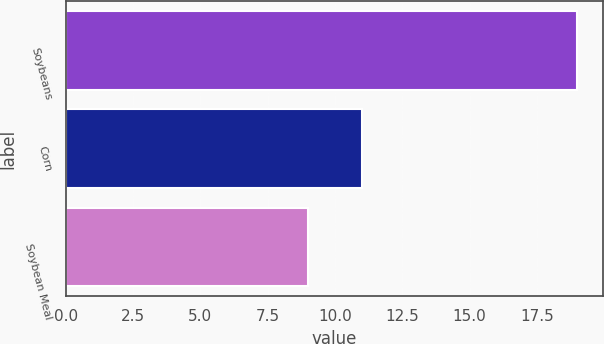Convert chart. <chart><loc_0><loc_0><loc_500><loc_500><bar_chart><fcel>Soybeans<fcel>Corn<fcel>Soybean Meal<nl><fcel>19<fcel>11<fcel>9<nl></chart> 